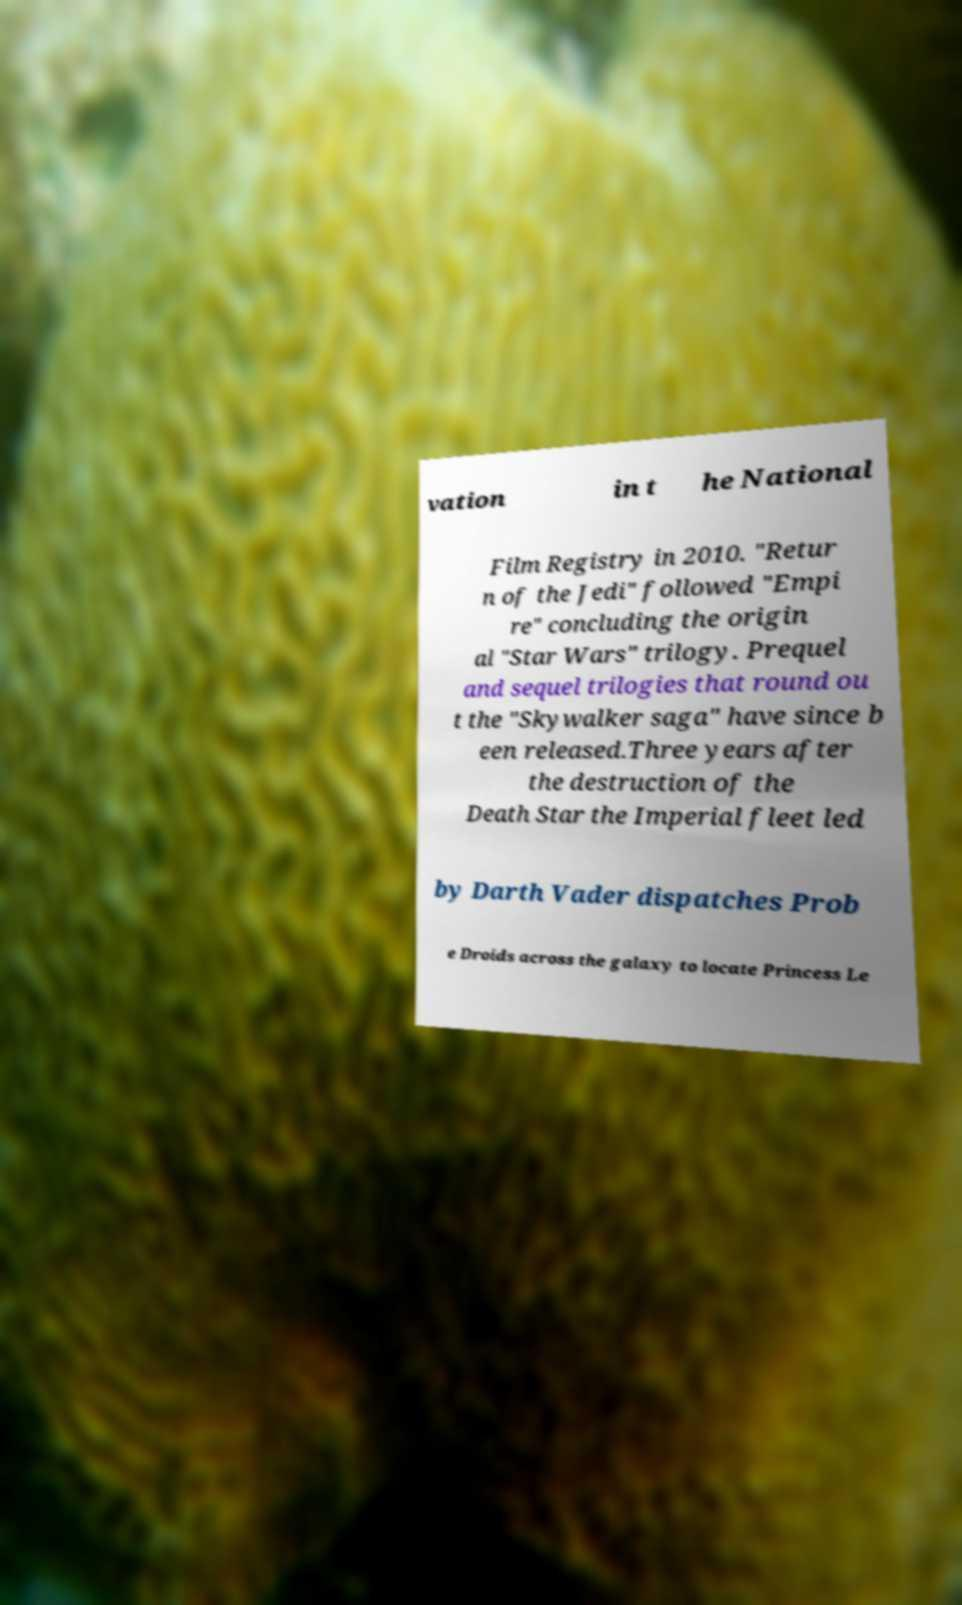Can you accurately transcribe the text from the provided image for me? vation in t he National Film Registry in 2010. "Retur n of the Jedi" followed "Empi re" concluding the origin al "Star Wars" trilogy. Prequel and sequel trilogies that round ou t the "Skywalker saga" have since b een released.Three years after the destruction of the Death Star the Imperial fleet led by Darth Vader dispatches Prob e Droids across the galaxy to locate Princess Le 